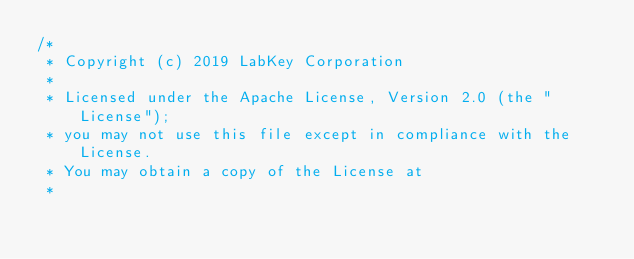Convert code to text. <code><loc_0><loc_0><loc_500><loc_500><_Java_>/*
 * Copyright (c) 2019 LabKey Corporation
 *
 * Licensed under the Apache License, Version 2.0 (the "License");
 * you may not use this file except in compliance with the License.
 * You may obtain a copy of the License at
 *</code> 